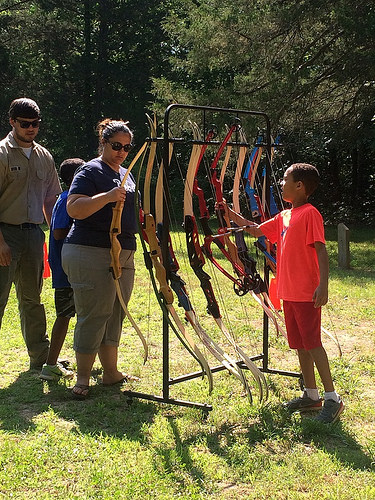<image>
Can you confirm if the shirt is on the woman? No. The shirt is not positioned on the woman. They may be near each other, but the shirt is not supported by or resting on top of the woman. Is the woman behind the boy? No. The woman is not behind the boy. From this viewpoint, the woman appears to be positioned elsewhere in the scene. 